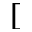Convert formula to latex. <formula><loc_0><loc_0><loc_500><loc_500>[</formula> 